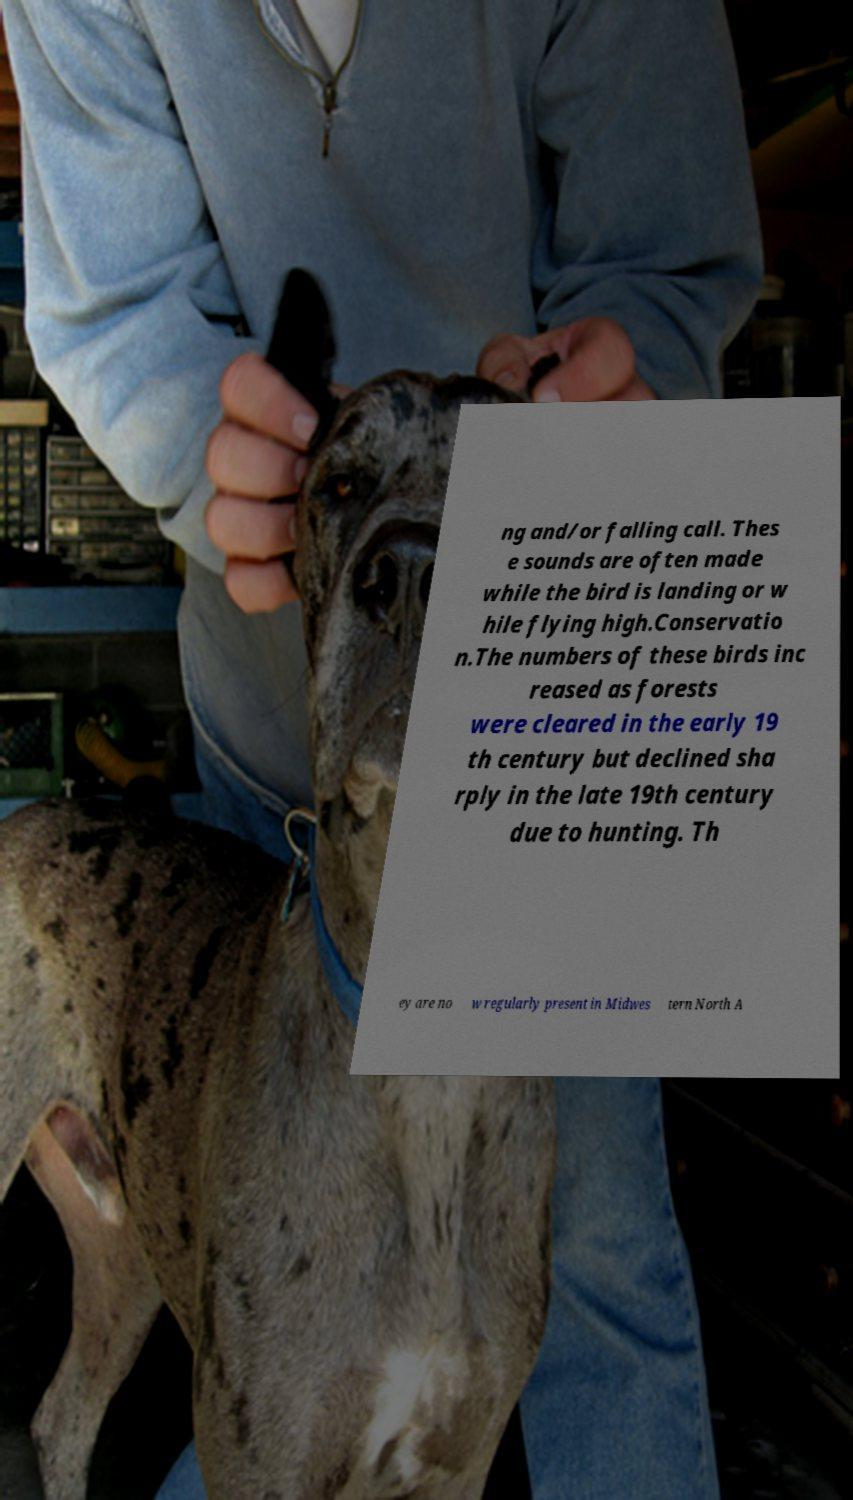Could you extract and type out the text from this image? ng and/or falling call. Thes e sounds are often made while the bird is landing or w hile flying high.Conservatio n.The numbers of these birds inc reased as forests were cleared in the early 19 th century but declined sha rply in the late 19th century due to hunting. Th ey are no w regularly present in Midwes tern North A 